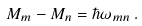Convert formula to latex. <formula><loc_0><loc_0><loc_500><loc_500>M _ { m } - M _ { n } = \hbar { \omega } _ { m n } \, .</formula> 